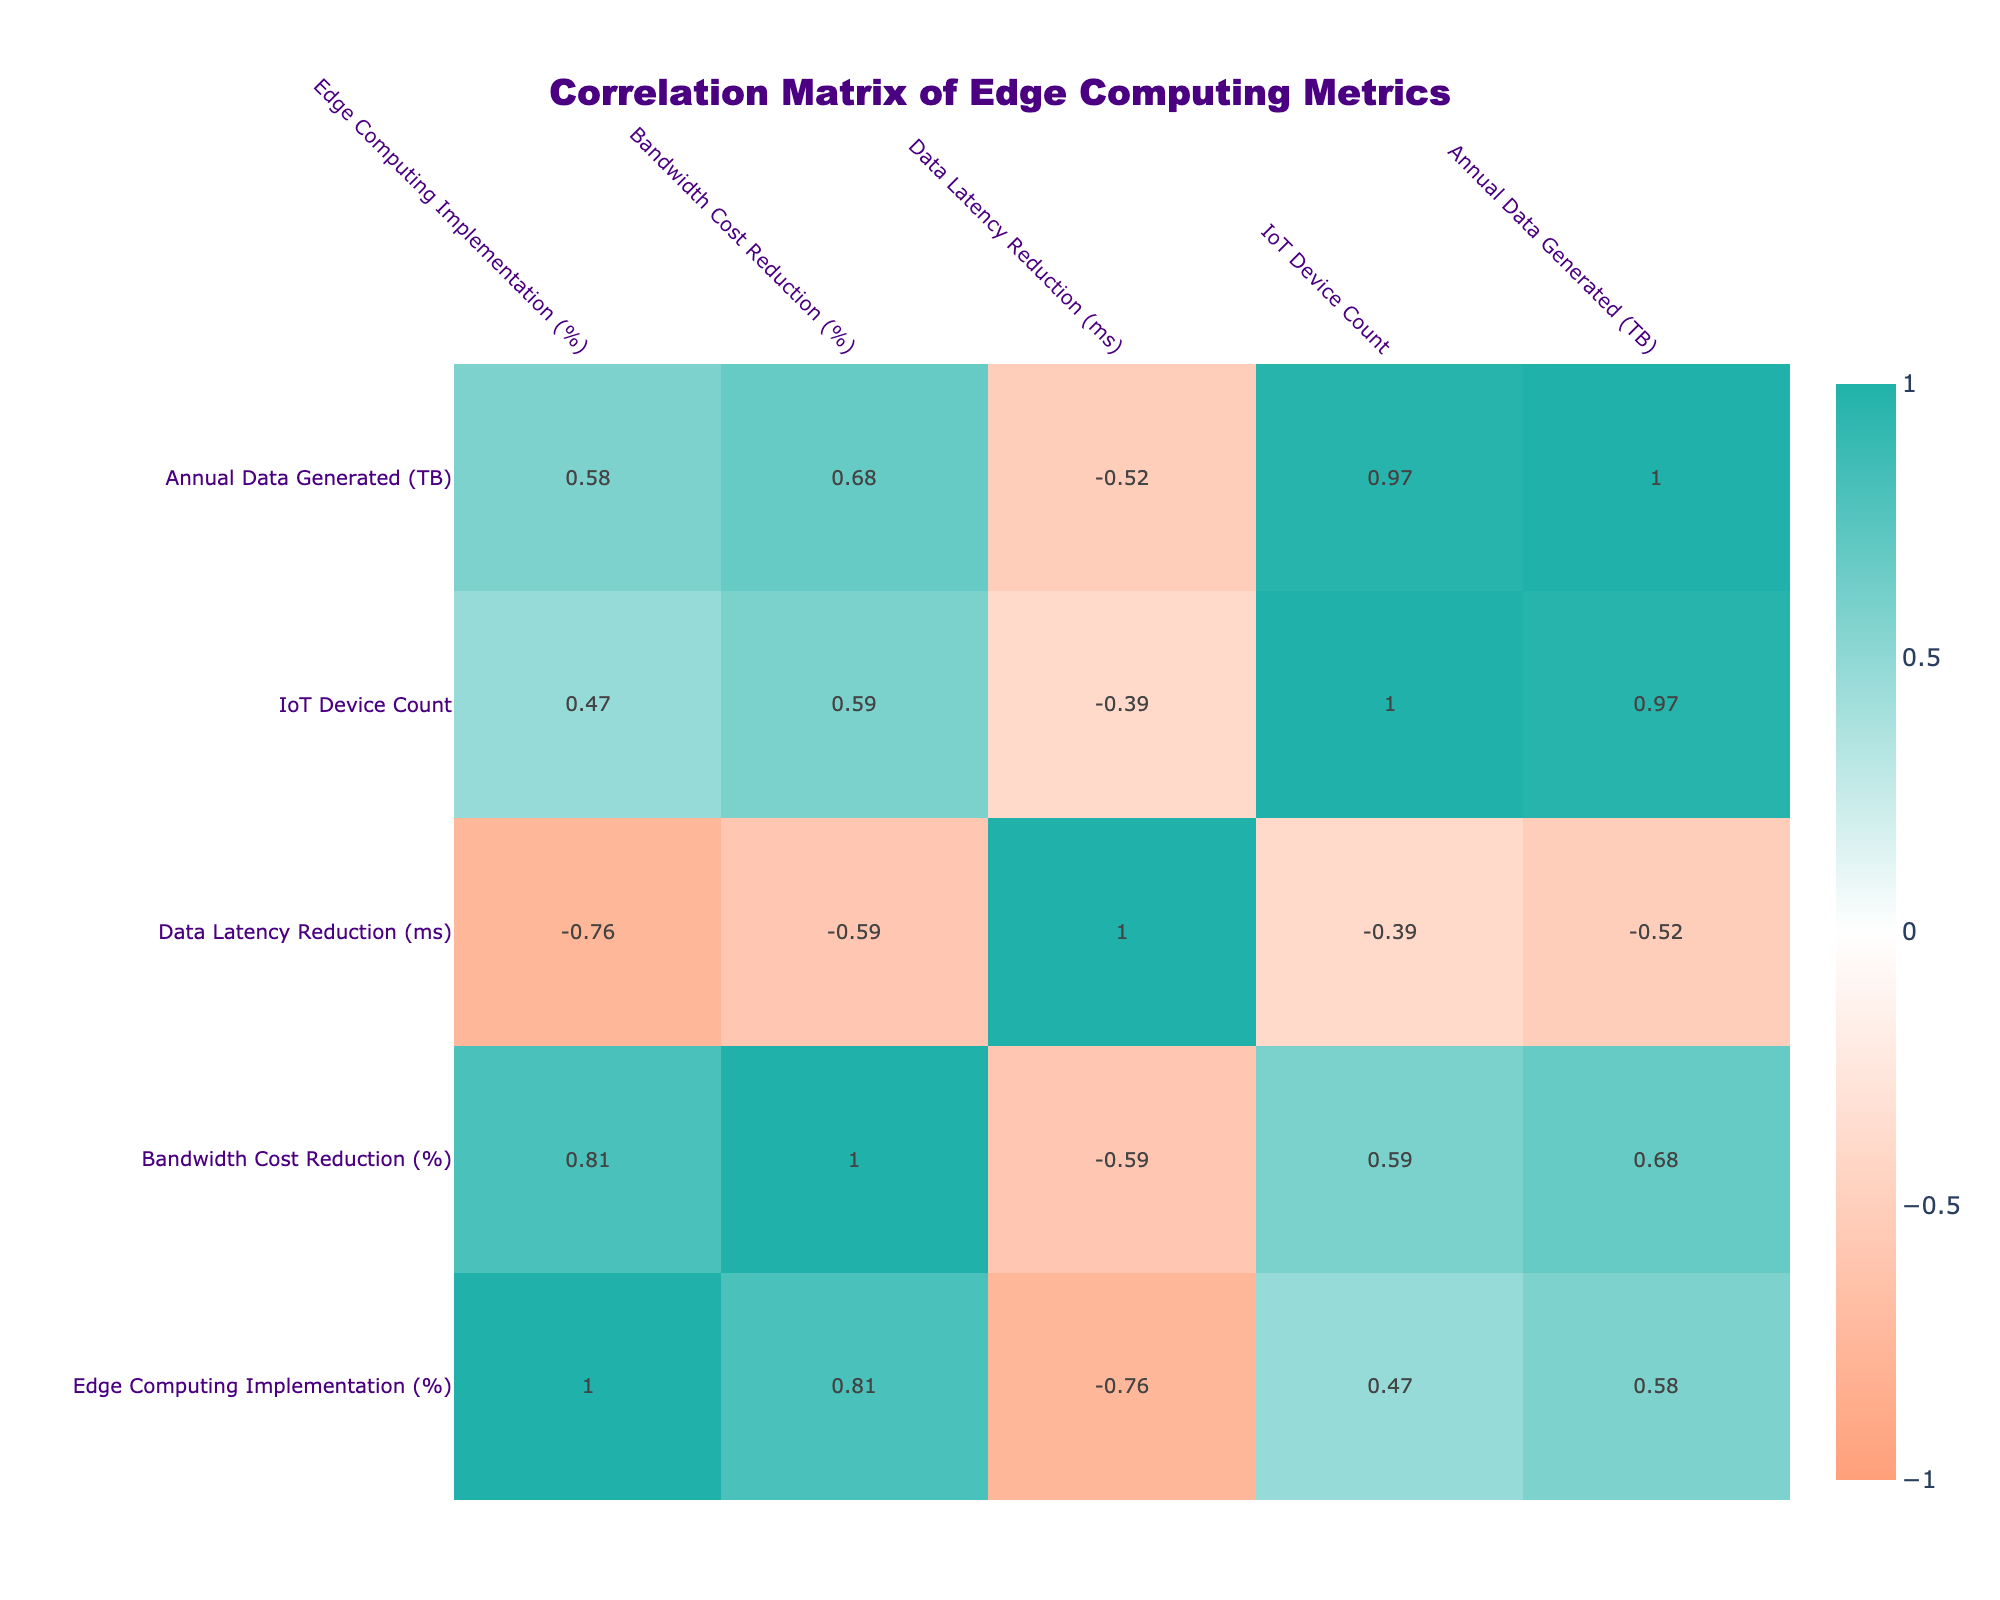What is the bandwidth cost reduction percentage for the Telecommunications industry? According to the table, the bandwidth cost reduction percentage for the Telecommunications industry is listed directly in its row.
Answer: 40 Which industry has the highest percentage of Edge Computing implementation? The row for the Telecommunications industry shows an implementation percentage of 90%, which is the highest value when compared to other industries in the table.
Answer: Telecommunications What is the average bandwidth cost reduction for industries with more than 20% Edge Computing implementation? The industries with more than 20% implementation are Healthcare (30%), Manufacturing (25%), Telecommunications (40%), Transportation (35%), and Financial Services (30%). Summing these percentages: 30 + 25 + 40 + 35 + 30 = 160. Dividing by the number of industries (5), we get an average of 160 / 5 = 32%.
Answer: 32 True or False: The Agriculture industry has a higher bandwidth cost reduction percentage than the Energy industry. Looking at the table, the Agriculture industry has a reduction percentage of 15%, while the Energy industry has a higher reduction percentage of 20%. This means the statement is false.
Answer: False Which industry has the lowest data latency reduction and what is its value? By examining the data, the Agriculture industry shows the lowest data latency reduction at 35 ms, which is found in its row.
Answer: 35 ms What is the total IoT device count in the Smart Cities and Retail industries combined? The IoT device count for Smart Cities is 30,000 and for Retail, it is 20,000. Adding these counts together gives: 30,000 + 20,000 = 50,000.
Answer: 50,000 Which industry shows the greatest data latency reduction and what is the percentage difference compared to the lowest? From the table, the Smart Cities industry has the greatest data latency reduction of 50 ms, while the Agriculture industry has the lowest at 35 ms. The percentage difference is calculated by: 50 - 35 = 15 ms.
Answer: 15 ms Is the Bandwidth Cost Reduction percentage for Manufacturing greater than 20%? The Bandwidth Cost Reduction percentage for Manufacturing is listed as 25%, which is indeed greater than 20%.
Answer: Yes Which industry out of Healthcare, Telecommunications, and Financial Services has the highest annual data generated? From the table, Telecommunications has an annual data generation of 1,500 TB, Healthcare has 500 TB, and Financial Services has 700 TB. Comparing these values, Telecommunications has the highest.
Answer: Telecommunications 